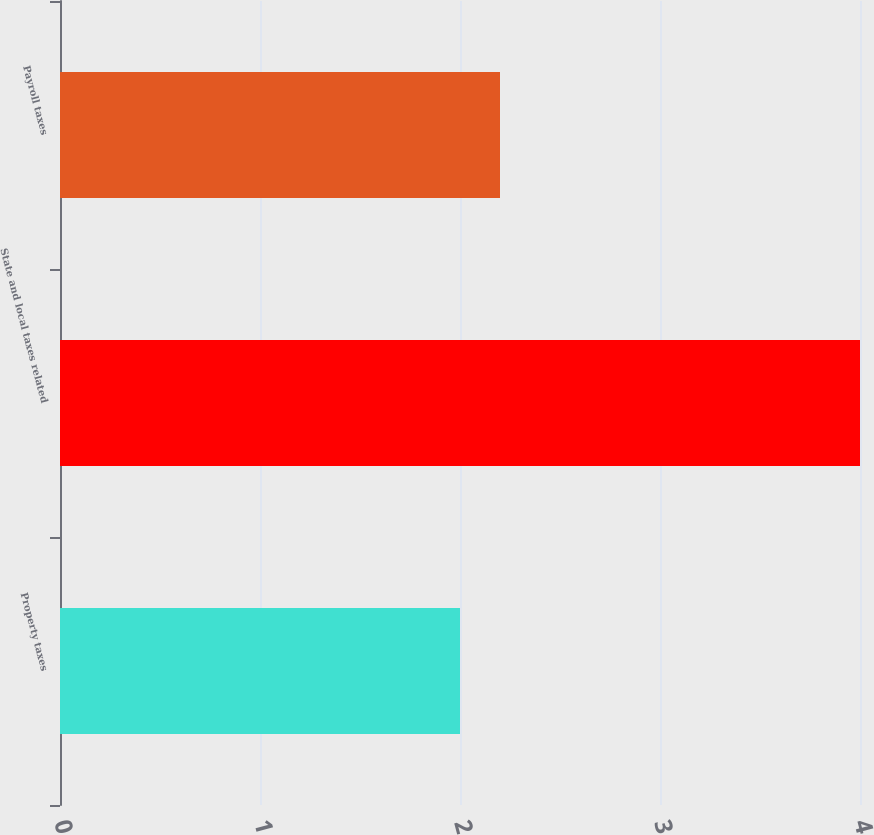Convert chart. <chart><loc_0><loc_0><loc_500><loc_500><bar_chart><fcel>Property taxes<fcel>State and local taxes related<fcel>Payroll taxes<nl><fcel>2<fcel>4<fcel>2.2<nl></chart> 